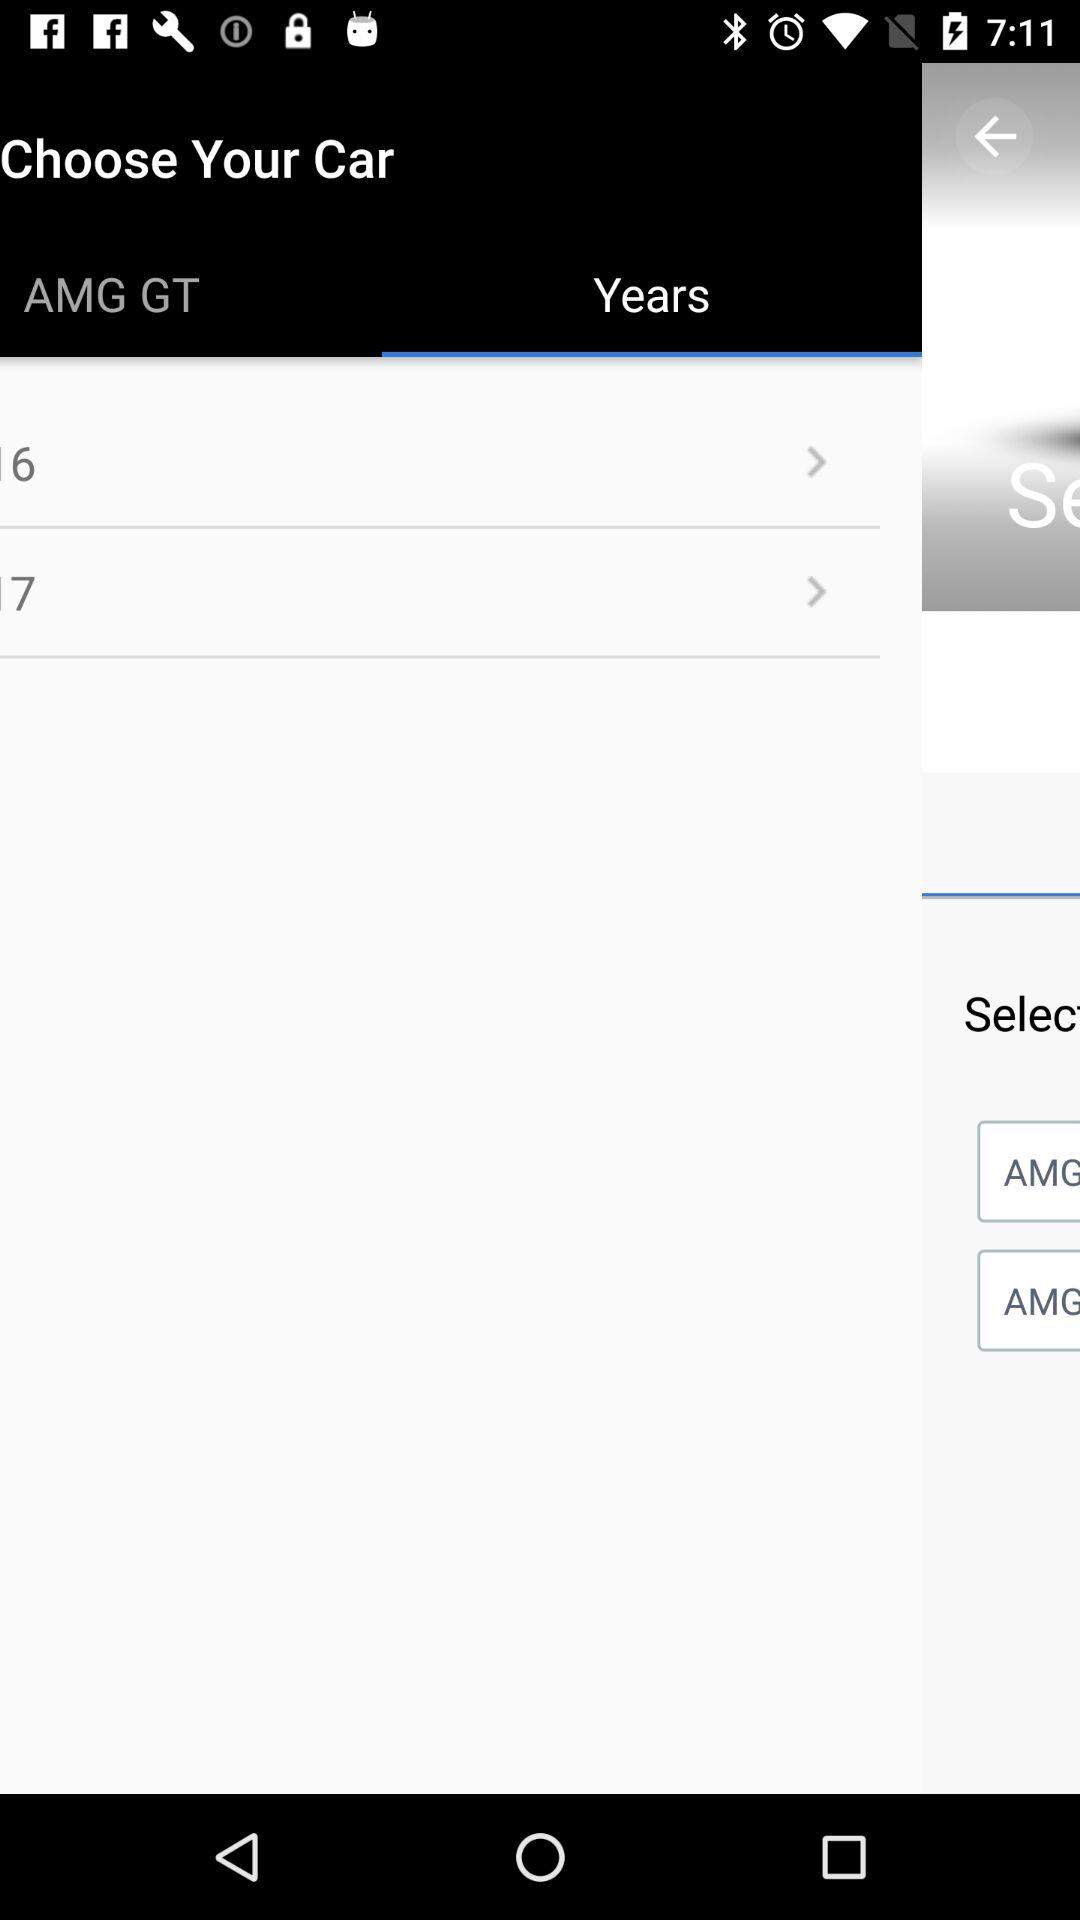How many years are available to choose from?
Answer the question using a single word or phrase. 2 